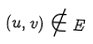Convert formula to latex. <formula><loc_0><loc_0><loc_500><loc_500>( u , v ) \notin E</formula> 